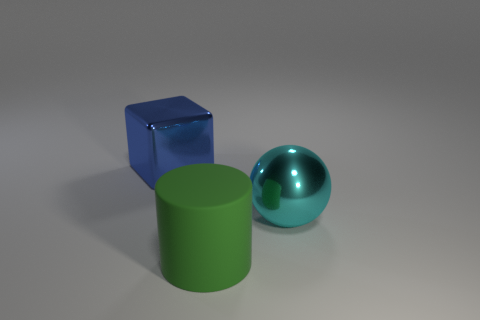How many large blue metallic objects are there?
Provide a short and direct response. 1. What number of things are either objects on the left side of the cyan shiny object or cylinders?
Your response must be concise. 2. Does the large metallic object behind the cyan metal sphere have the same color as the shiny sphere?
Ensure brevity in your answer.  No. How many other objects are the same color as the metallic sphere?
Keep it short and to the point. 0. How many big objects are blue things or cyan things?
Provide a succinct answer. 2. Is the number of big blue shiny things greater than the number of small red shiny spheres?
Provide a succinct answer. Yes. Is the material of the large cyan object the same as the big green cylinder?
Your answer should be very brief. No. Is there any other thing that is made of the same material as the big green thing?
Your answer should be compact. No. Is the number of shiny balls behind the blue metallic cube greater than the number of small gray metallic objects?
Provide a short and direct response. No. Is the sphere the same color as the large metal block?
Your response must be concise. No. 